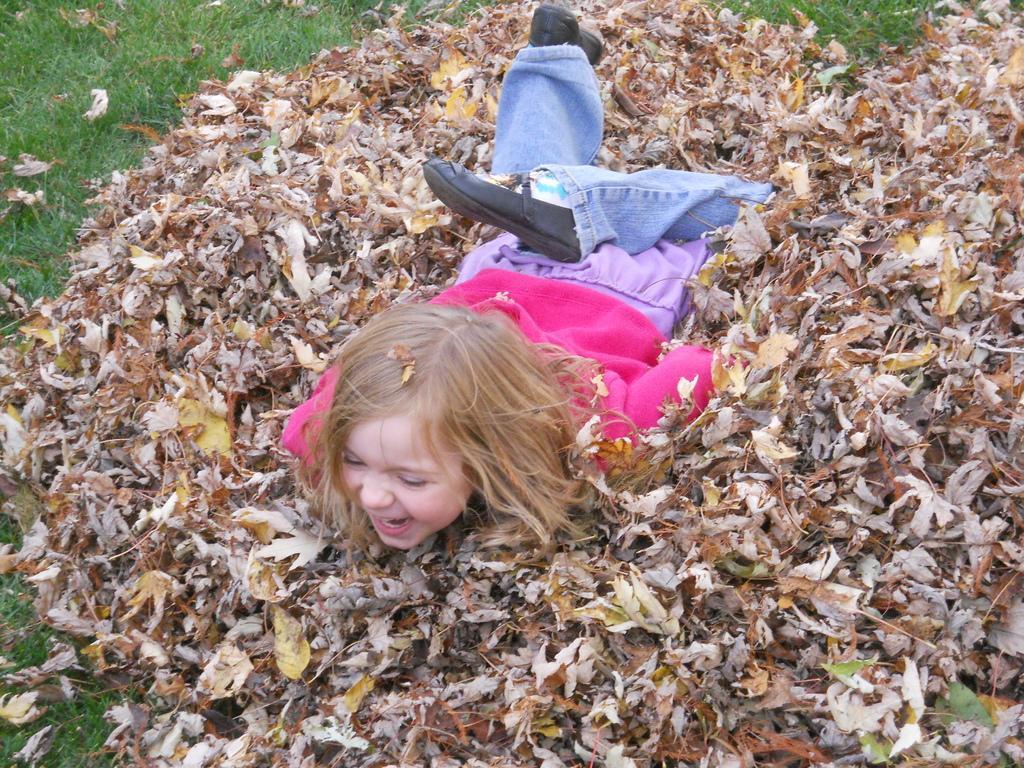In one or two sentences, can you explain what this image depicts? In this image we can see a kid wearing pink color sweater, blue color jeans, black color jeans sleeping on the dry leaves which are on ground and there is grass. 